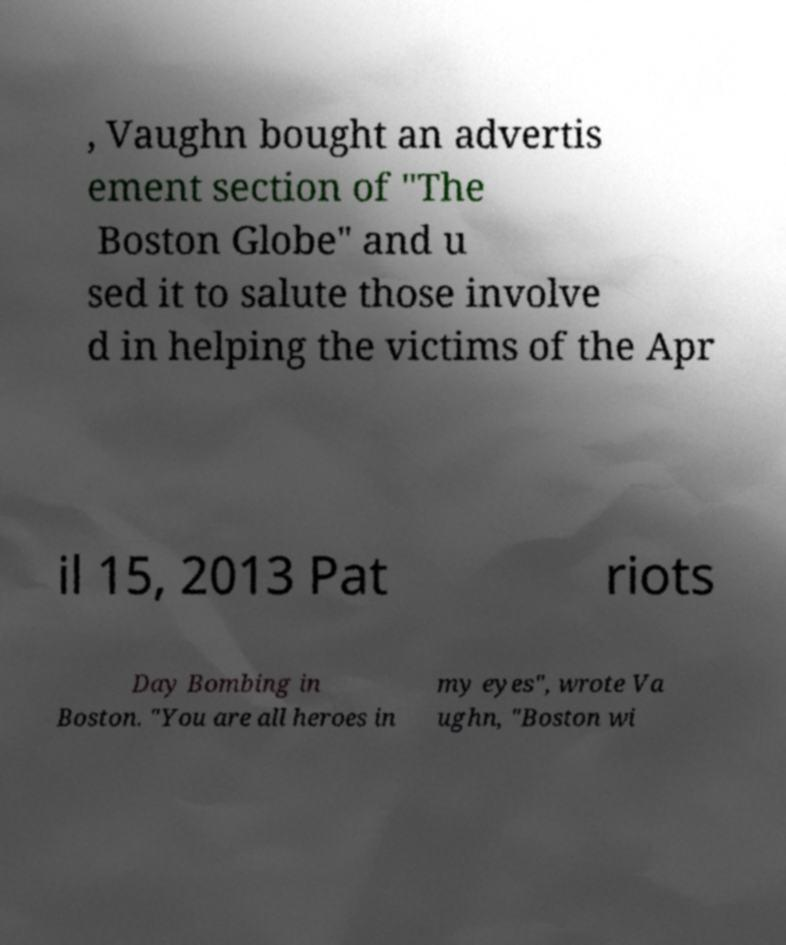There's text embedded in this image that I need extracted. Can you transcribe it verbatim? , Vaughn bought an advertis ement section of "The Boston Globe" and u sed it to salute those involve d in helping the victims of the Apr il 15, 2013 Pat riots Day Bombing in Boston. "You are all heroes in my eyes", wrote Va ughn, "Boston wi 